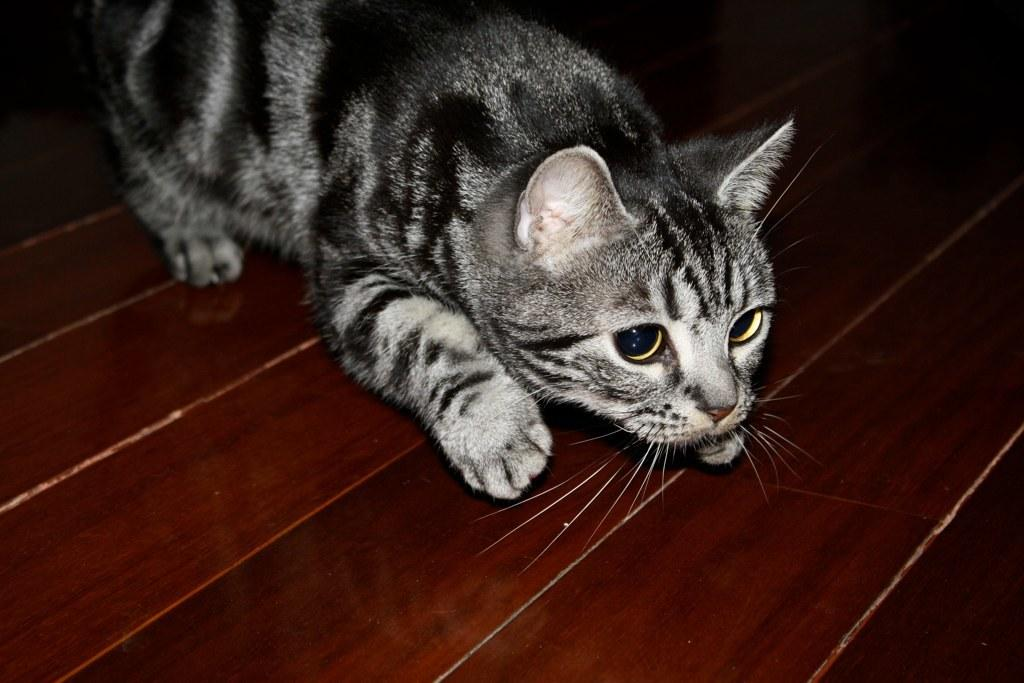What is the color of the surface in the image? The surface in the image is brown-colored. What type of animal can be seen on the surface? There is a grey-colored cat on the surface. How much pain is the cat experiencing in the image? There is no indication in the image that the cat is experiencing any pain. Can you see any cobwebs in the image? There is no mention of cobwebs in the image, and therefore none can be seen. 